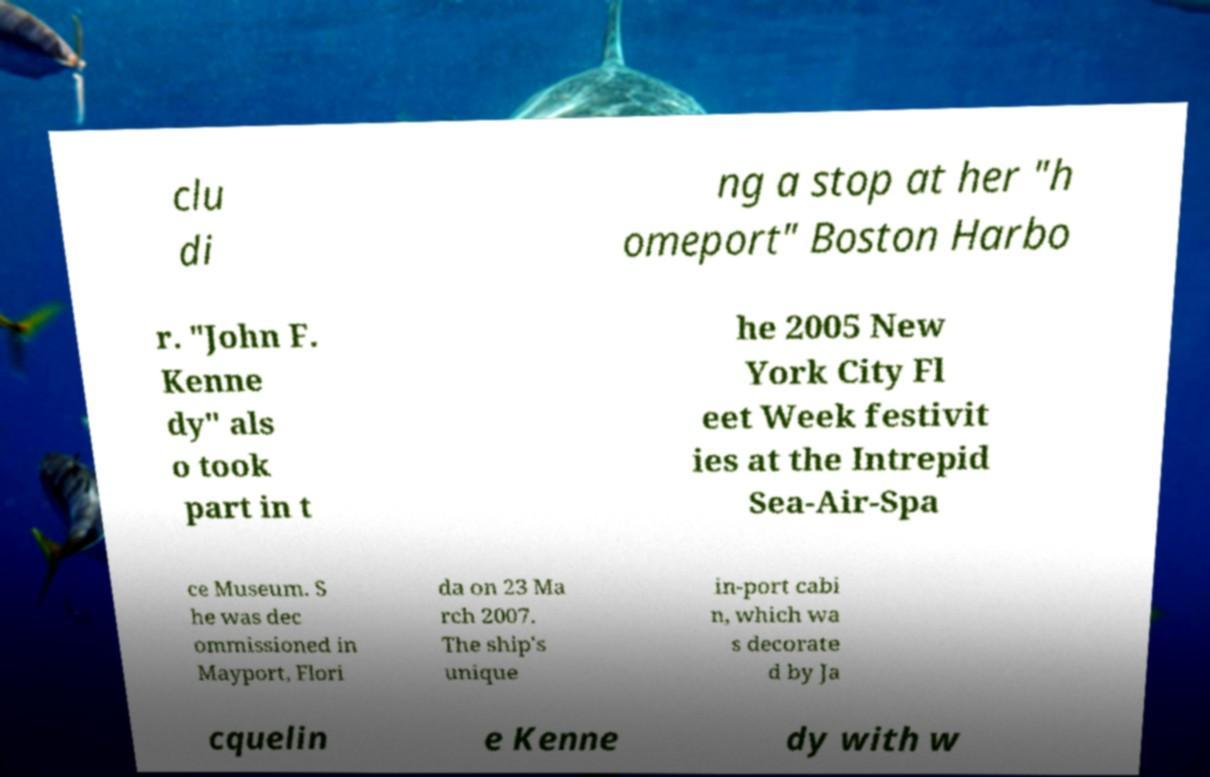Please read and relay the text visible in this image. What does it say? clu di ng a stop at her "h omeport" Boston Harbo r. "John F. Kenne dy" als o took part in t he 2005 New York City Fl eet Week festivit ies at the Intrepid Sea-Air-Spa ce Museum. S he was dec ommissioned in Mayport, Flori da on 23 Ma rch 2007. The ship's unique in-port cabi n, which wa s decorate d by Ja cquelin e Kenne dy with w 